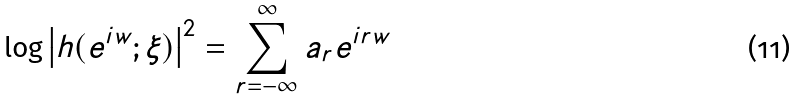Convert formula to latex. <formula><loc_0><loc_0><loc_500><loc_500>\log \left | h ( e ^ { i w } ; \xi ) \right | ^ { 2 } = \sum _ { r = - \infty } ^ { \infty } a _ { r } e ^ { i r w }</formula> 